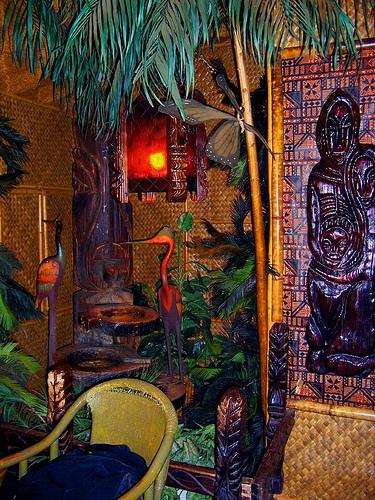What style or theme does the room in the image represent? The room in the image reflects a Tiki bar theme, which is inspired by tropical South Pacific islands. This is evident from the thatched materials, bamboo, tropical plant decorations, and Polynesian art. 